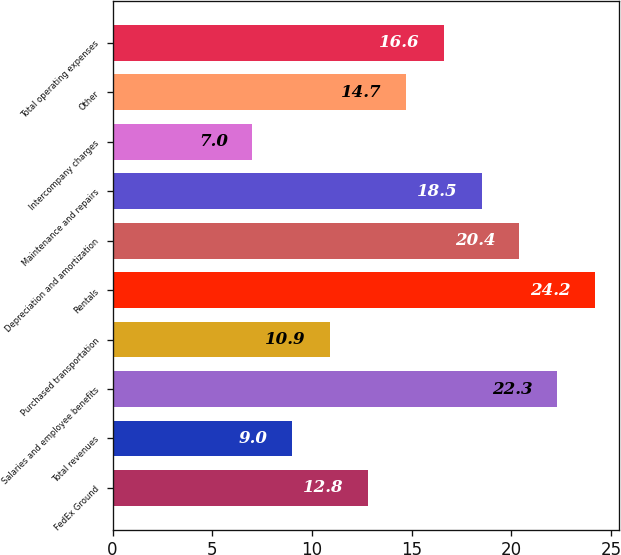<chart> <loc_0><loc_0><loc_500><loc_500><bar_chart><fcel>FedEx Ground<fcel>Total revenues<fcel>Salaries and employee benefits<fcel>Purchased transportation<fcel>Rentals<fcel>Depreciation and amortization<fcel>Maintenance and repairs<fcel>Intercompany charges<fcel>Other<fcel>Total operating expenses<nl><fcel>12.8<fcel>9<fcel>22.3<fcel>10.9<fcel>24.2<fcel>20.4<fcel>18.5<fcel>7<fcel>14.7<fcel>16.6<nl></chart> 